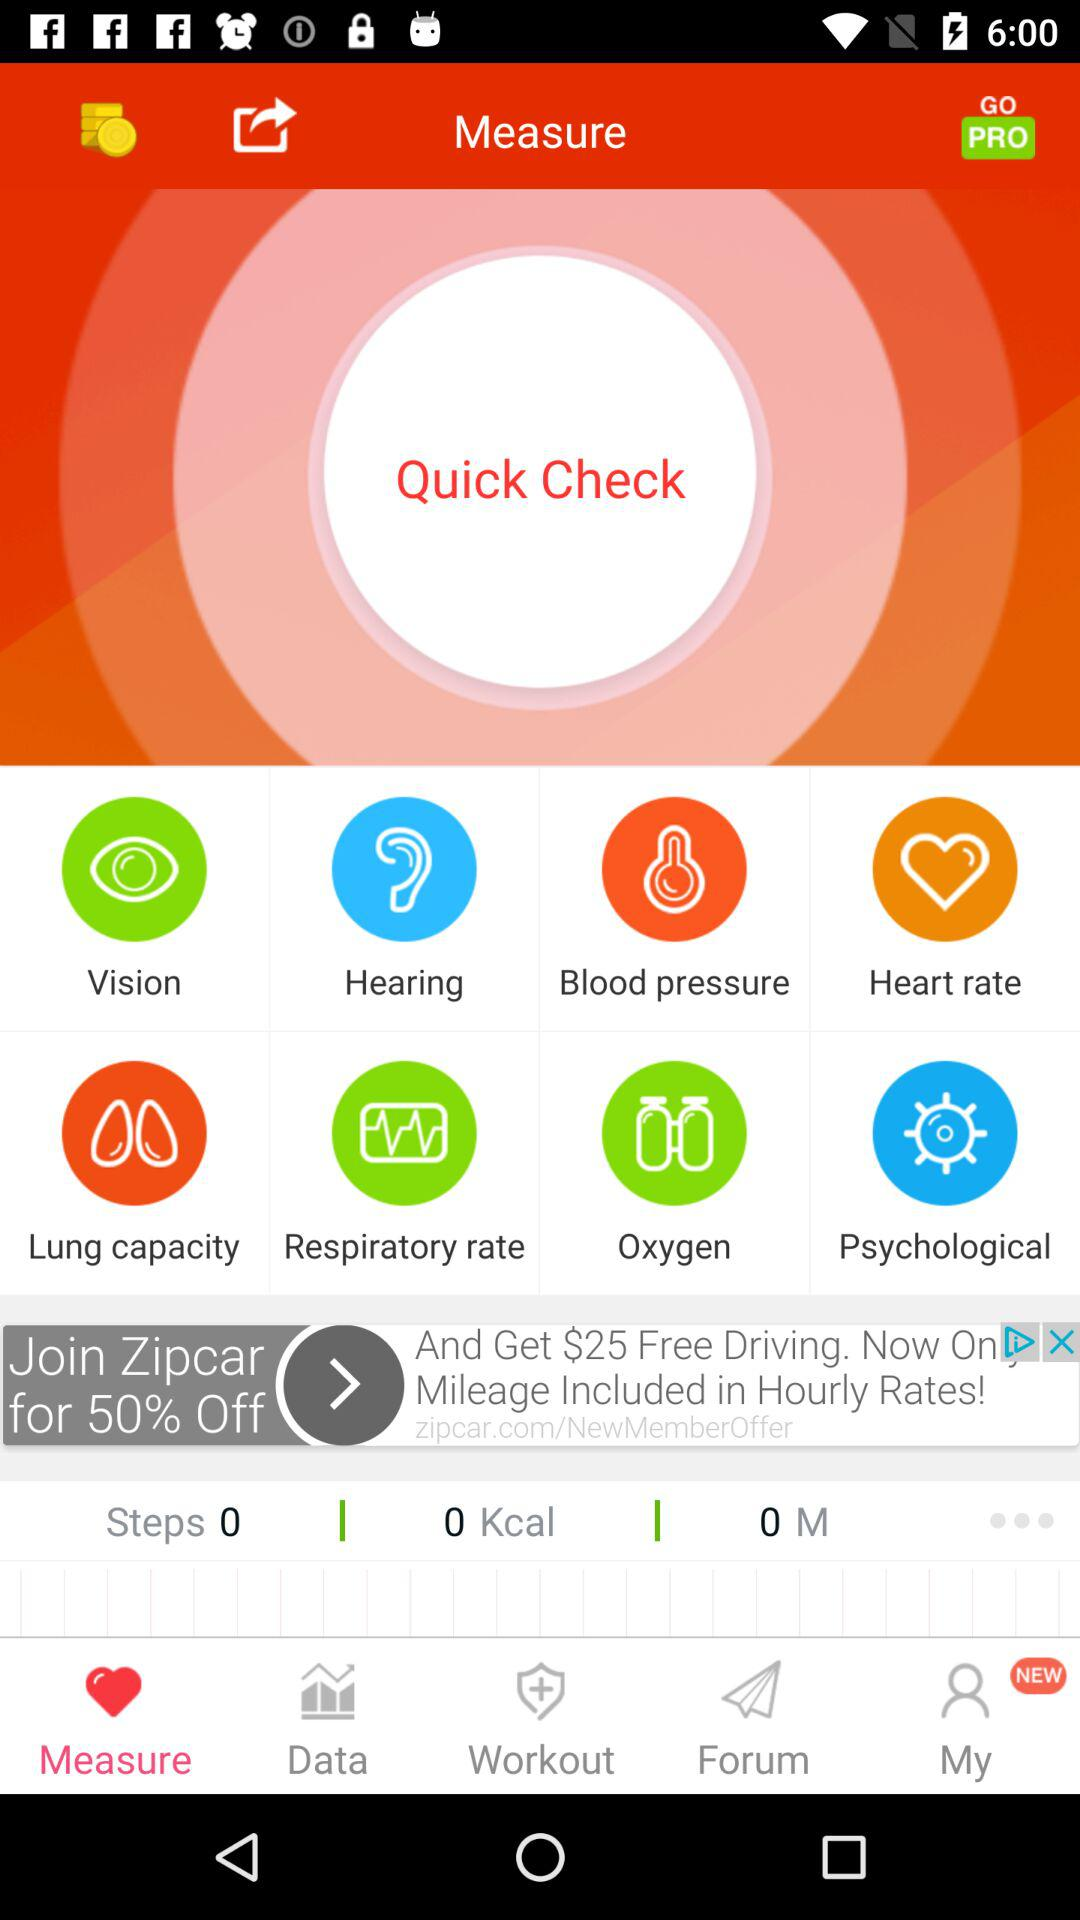How many steps have been counted? The number of steps is 0. 